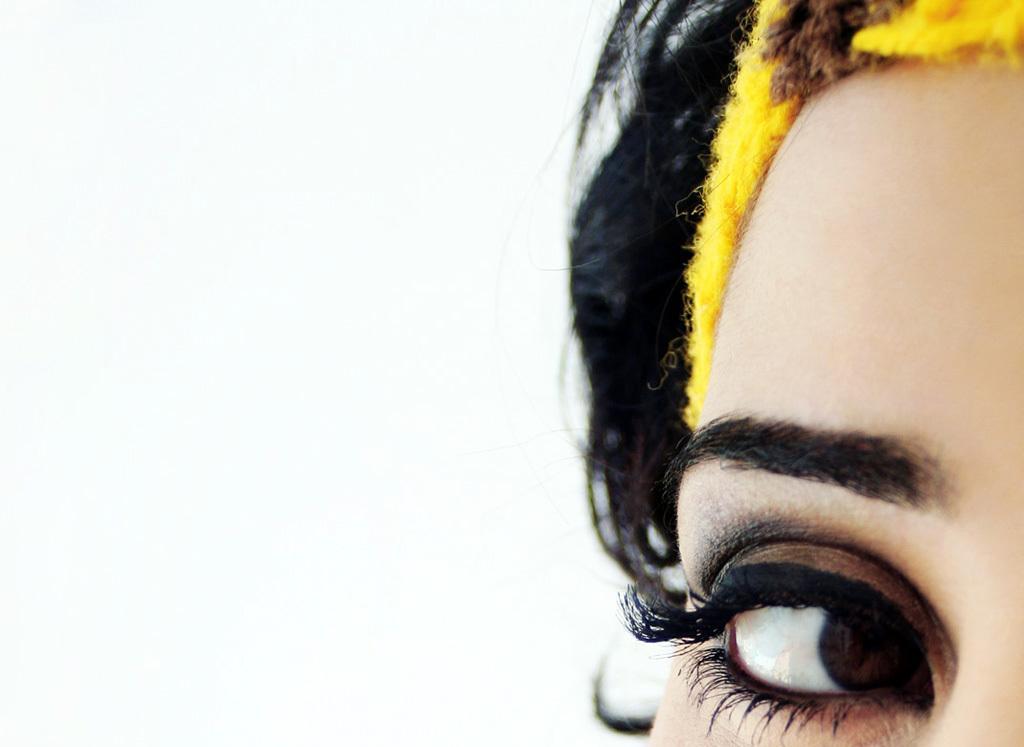Please provide a concise description of this image. Right side of the image we can see a woman eye. Above the eye there is an eyebrow. Background it is in white color. 